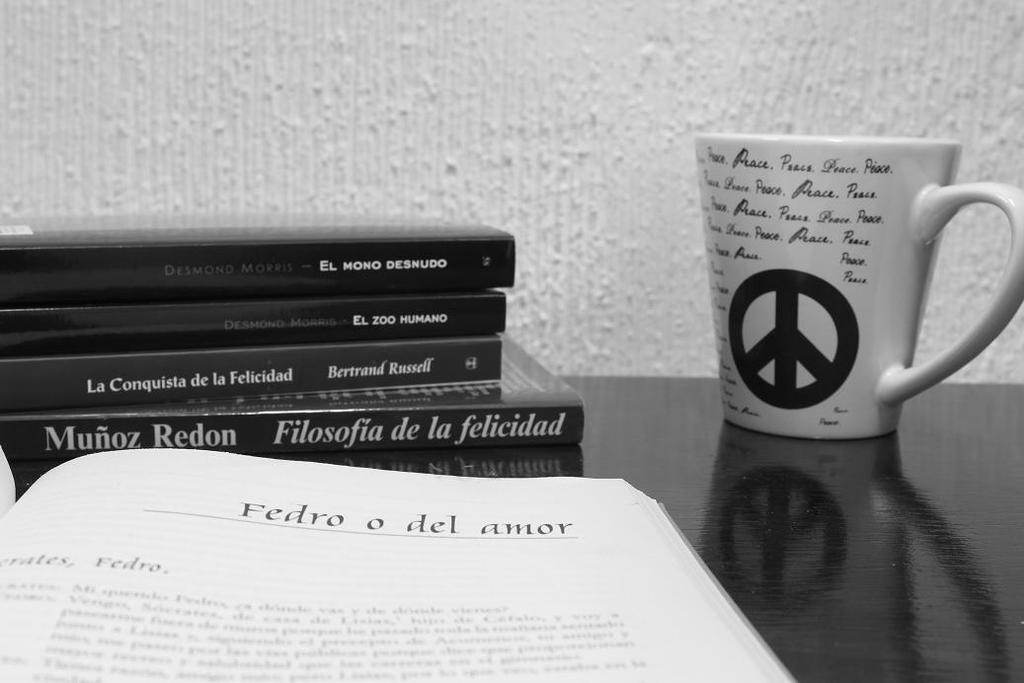What's the name at the top of the right page?
Your answer should be very brief. Fedro o del amor. Who is one of the authors shown here?
Your answer should be compact. Munoz redon. 